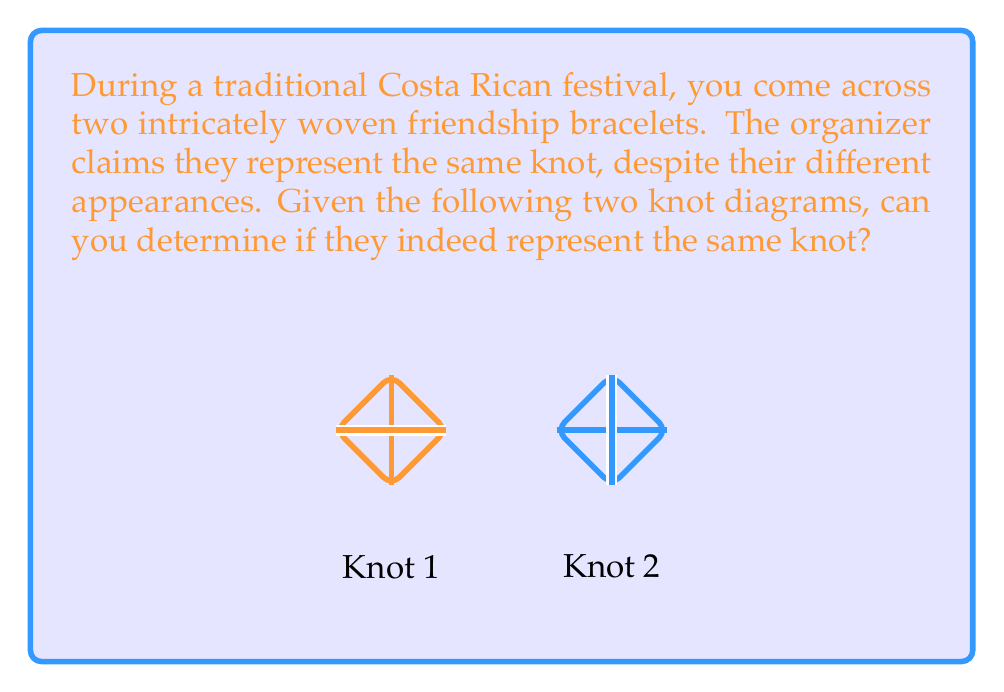Help me with this question. To determine if two knot diagrams represent the same knot, we need to analyze their properties and use knot invariants. Let's follow these steps:

1. Identify the knot type:
   Both diagrams appear to represent the trefoil knot, which is the simplest non-trivial knot.

2. Count crossings:
   Both knots have exactly 3 crossings.

3. Analyze crossing types:
   In Knot 1, all crossings are right-handed (over-under).
   In Knot 2, all crossings are left-handed (under-over).

4. Consider Reidemeister moves:
   We can transform one diagram into the other using Reidemeister moves:
   a) Rotate Knot 2 by 180 degrees.
   b) Apply a type III Reidemeister move to align the crossings.

5. Check chirality:
   The trefoil knot is chiral, meaning its mirror image is not ambient isotopic to itself.
   Knot 2 is the mirror image of Knot 1.

6. Consider knot invariants:
   The Jones polynomial for both knots would be $t + t^3 - t^4$, which is consistent for mirror images of the trefoil knot.

Despite their visual differences, these knots are topologically equivalent. They represent the left-handed and right-handed versions of the trefoil knot, which are mirror images of each other but not ambient isotopic.
Answer: Yes, they represent the same knot (mirror images of the trefoil knot). 